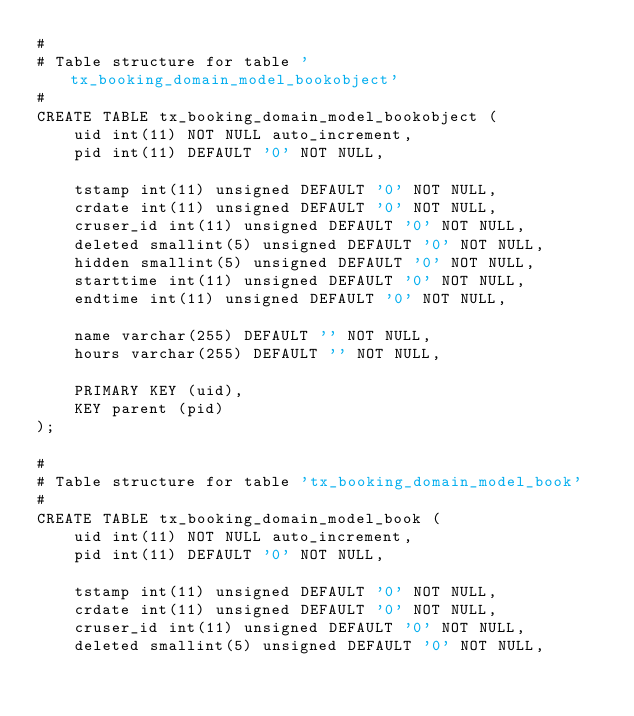Convert code to text. <code><loc_0><loc_0><loc_500><loc_500><_SQL_>#
# Table structure for table 'tx_booking_domain_model_bookobject'
#
CREATE TABLE tx_booking_domain_model_bookobject (
	uid int(11) NOT NULL auto_increment,
	pid int(11) DEFAULT '0' NOT NULL,

	tstamp int(11) unsigned DEFAULT '0' NOT NULL,
	crdate int(11) unsigned DEFAULT '0' NOT NULL,
	cruser_id int(11) unsigned DEFAULT '0' NOT NULL,
	deleted smallint(5) unsigned DEFAULT '0' NOT NULL,
	hidden smallint(5) unsigned DEFAULT '0' NOT NULL,
	starttime int(11) unsigned DEFAULT '0' NOT NULL,
	endtime int(11) unsigned DEFAULT '0' NOT NULL,

	name varchar(255) DEFAULT '' NOT NULL,
	hours varchar(255) DEFAULT '' NOT NULL,

	PRIMARY KEY (uid),
	KEY parent (pid)
);

#
# Table structure for table 'tx_booking_domain_model_book'
#
CREATE TABLE tx_booking_domain_model_book (
	uid int(11) NOT NULL auto_increment,
	pid int(11) DEFAULT '0' NOT NULL,

	tstamp int(11) unsigned DEFAULT '0' NOT NULL,
	crdate int(11) unsigned DEFAULT '0' NOT NULL,
	cruser_id int(11) unsigned DEFAULT '0' NOT NULL,
	deleted smallint(5) unsigned DEFAULT '0' NOT NULL,</code> 